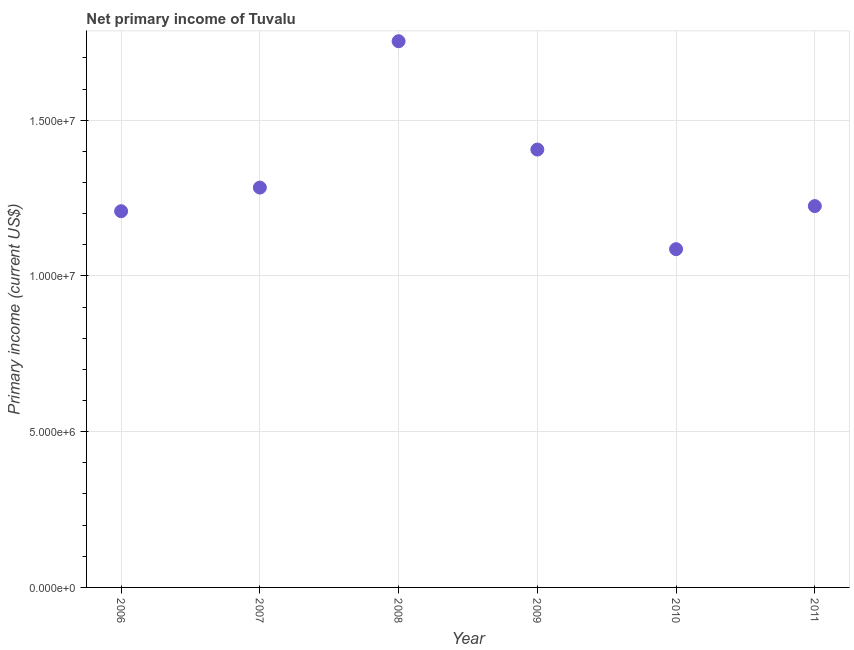What is the amount of primary income in 2009?
Your answer should be very brief. 1.41e+07. Across all years, what is the maximum amount of primary income?
Your response must be concise. 1.75e+07. Across all years, what is the minimum amount of primary income?
Your answer should be very brief. 1.09e+07. In which year was the amount of primary income minimum?
Offer a very short reply. 2010. What is the sum of the amount of primary income?
Ensure brevity in your answer.  7.96e+07. What is the difference between the amount of primary income in 2008 and 2010?
Ensure brevity in your answer.  6.68e+06. What is the average amount of primary income per year?
Give a very brief answer. 1.33e+07. What is the median amount of primary income?
Provide a short and direct response. 1.25e+07. In how many years, is the amount of primary income greater than 16000000 US$?
Provide a succinct answer. 1. What is the ratio of the amount of primary income in 2008 to that in 2010?
Make the answer very short. 1.61. Is the amount of primary income in 2007 less than that in 2010?
Offer a very short reply. No. Is the difference between the amount of primary income in 2006 and 2010 greater than the difference between any two years?
Offer a terse response. No. What is the difference between the highest and the second highest amount of primary income?
Ensure brevity in your answer.  3.48e+06. What is the difference between the highest and the lowest amount of primary income?
Make the answer very short. 6.68e+06. In how many years, is the amount of primary income greater than the average amount of primary income taken over all years?
Your answer should be very brief. 2. Does the amount of primary income monotonically increase over the years?
Make the answer very short. No. How many dotlines are there?
Offer a very short reply. 1. How many years are there in the graph?
Your response must be concise. 6. Are the values on the major ticks of Y-axis written in scientific E-notation?
Provide a succinct answer. Yes. Does the graph contain grids?
Make the answer very short. Yes. What is the title of the graph?
Your response must be concise. Net primary income of Tuvalu. What is the label or title of the X-axis?
Give a very brief answer. Year. What is the label or title of the Y-axis?
Keep it short and to the point. Primary income (current US$). What is the Primary income (current US$) in 2006?
Provide a short and direct response. 1.21e+07. What is the Primary income (current US$) in 2007?
Ensure brevity in your answer.  1.28e+07. What is the Primary income (current US$) in 2008?
Provide a short and direct response. 1.75e+07. What is the Primary income (current US$) in 2009?
Give a very brief answer. 1.41e+07. What is the Primary income (current US$) in 2010?
Make the answer very short. 1.09e+07. What is the Primary income (current US$) in 2011?
Your answer should be compact. 1.22e+07. What is the difference between the Primary income (current US$) in 2006 and 2007?
Provide a succinct answer. -7.59e+05. What is the difference between the Primary income (current US$) in 2006 and 2008?
Keep it short and to the point. -5.46e+06. What is the difference between the Primary income (current US$) in 2006 and 2009?
Ensure brevity in your answer.  -1.98e+06. What is the difference between the Primary income (current US$) in 2006 and 2010?
Provide a short and direct response. 1.22e+06. What is the difference between the Primary income (current US$) in 2006 and 2011?
Offer a terse response. -1.65e+05. What is the difference between the Primary income (current US$) in 2007 and 2008?
Offer a terse response. -4.70e+06. What is the difference between the Primary income (current US$) in 2007 and 2009?
Provide a short and direct response. -1.22e+06. What is the difference between the Primary income (current US$) in 2007 and 2010?
Offer a terse response. 1.98e+06. What is the difference between the Primary income (current US$) in 2007 and 2011?
Offer a terse response. 5.94e+05. What is the difference between the Primary income (current US$) in 2008 and 2009?
Offer a very short reply. 3.48e+06. What is the difference between the Primary income (current US$) in 2008 and 2010?
Offer a terse response. 6.68e+06. What is the difference between the Primary income (current US$) in 2008 and 2011?
Ensure brevity in your answer.  5.29e+06. What is the difference between the Primary income (current US$) in 2009 and 2010?
Keep it short and to the point. 3.20e+06. What is the difference between the Primary income (current US$) in 2009 and 2011?
Your response must be concise. 1.81e+06. What is the difference between the Primary income (current US$) in 2010 and 2011?
Your answer should be very brief. -1.38e+06. What is the ratio of the Primary income (current US$) in 2006 to that in 2007?
Give a very brief answer. 0.94. What is the ratio of the Primary income (current US$) in 2006 to that in 2008?
Offer a terse response. 0.69. What is the ratio of the Primary income (current US$) in 2006 to that in 2009?
Your answer should be very brief. 0.86. What is the ratio of the Primary income (current US$) in 2006 to that in 2010?
Give a very brief answer. 1.11. What is the ratio of the Primary income (current US$) in 2007 to that in 2008?
Offer a very short reply. 0.73. What is the ratio of the Primary income (current US$) in 2007 to that in 2010?
Provide a succinct answer. 1.18. What is the ratio of the Primary income (current US$) in 2007 to that in 2011?
Offer a very short reply. 1.05. What is the ratio of the Primary income (current US$) in 2008 to that in 2009?
Provide a short and direct response. 1.25. What is the ratio of the Primary income (current US$) in 2008 to that in 2010?
Your response must be concise. 1.61. What is the ratio of the Primary income (current US$) in 2008 to that in 2011?
Your answer should be compact. 1.43. What is the ratio of the Primary income (current US$) in 2009 to that in 2010?
Offer a terse response. 1.29. What is the ratio of the Primary income (current US$) in 2009 to that in 2011?
Give a very brief answer. 1.15. What is the ratio of the Primary income (current US$) in 2010 to that in 2011?
Your answer should be very brief. 0.89. 